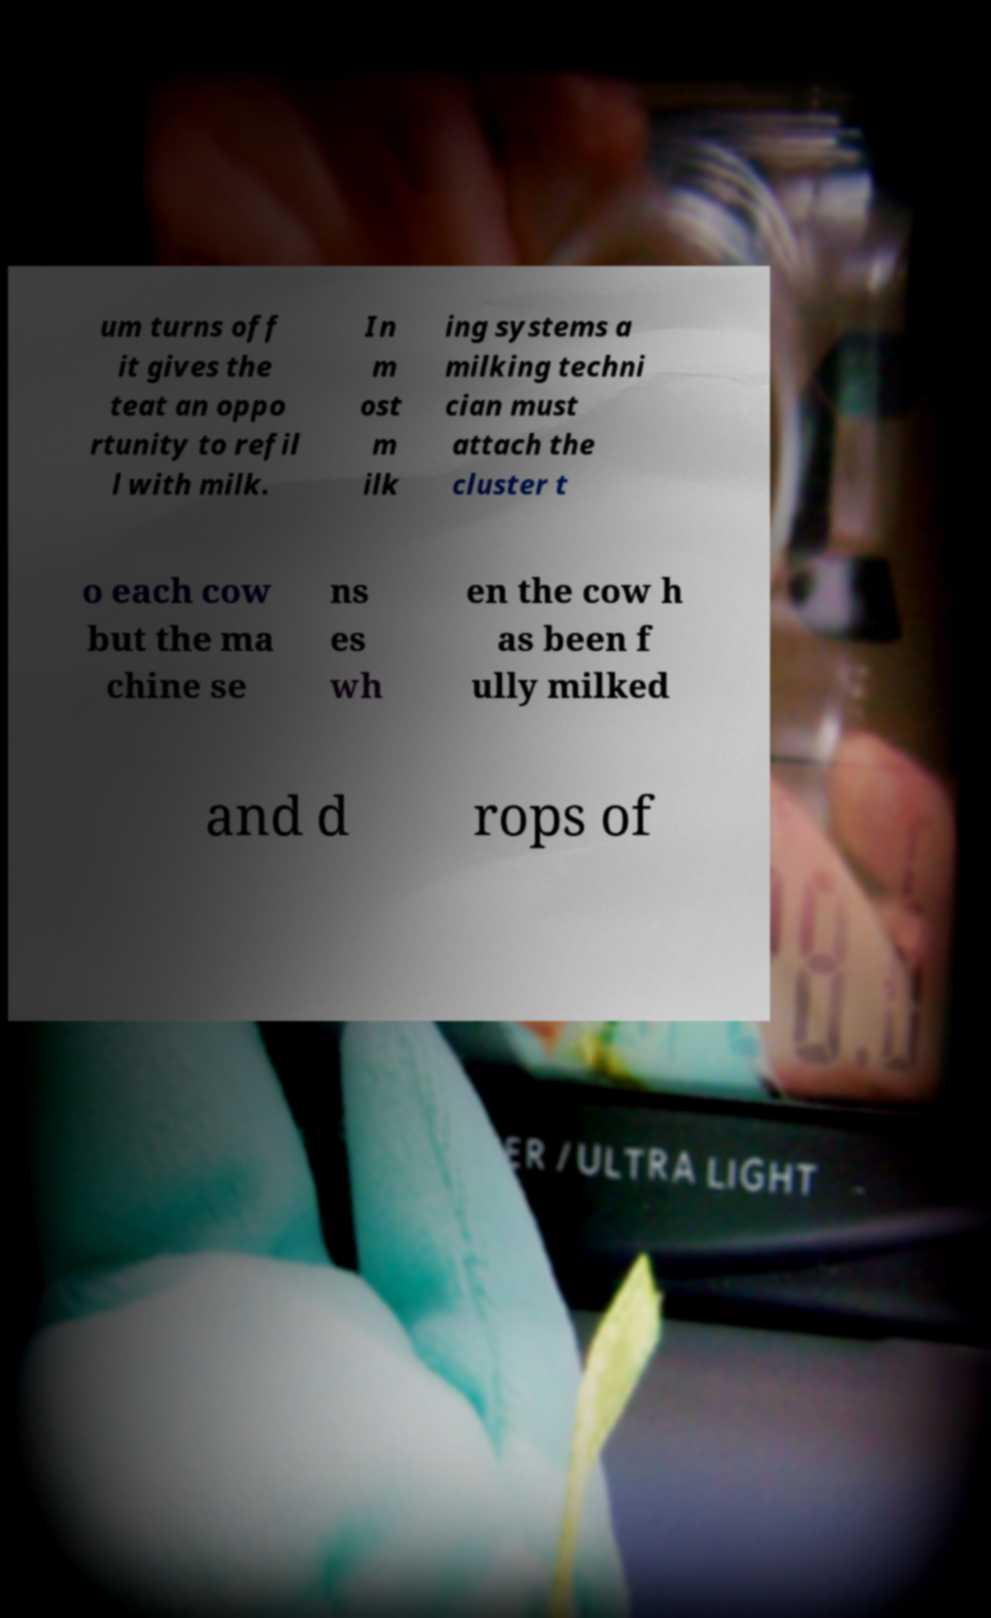I need the written content from this picture converted into text. Can you do that? um turns off it gives the teat an oppo rtunity to refil l with milk. In m ost m ilk ing systems a milking techni cian must attach the cluster t o each cow but the ma chine se ns es wh en the cow h as been f ully milked and d rops of 